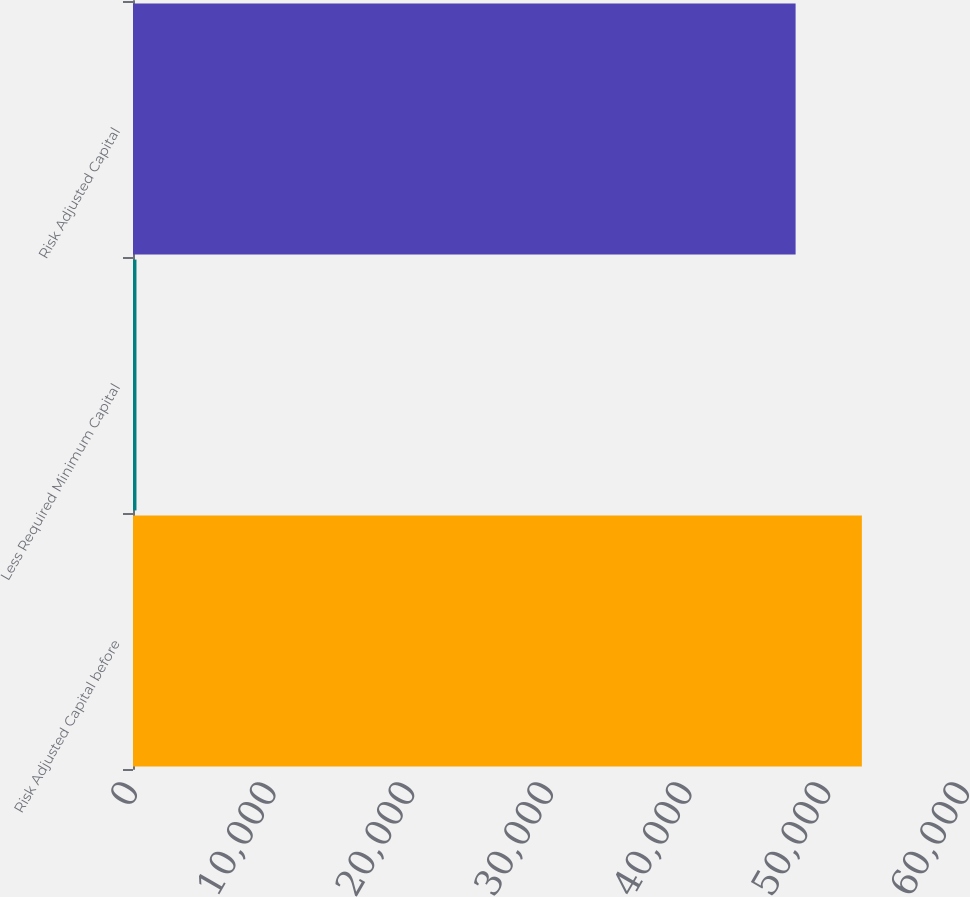Convert chart to OTSL. <chart><loc_0><loc_0><loc_500><loc_500><bar_chart><fcel>Risk Adjusted Capital before<fcel>Less Required Minimum Capital<fcel>Risk Adjusted Capital<nl><fcel>52561.3<fcel>250<fcel>47783<nl></chart> 